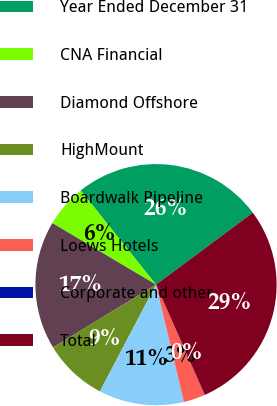Convert chart. <chart><loc_0><loc_0><loc_500><loc_500><pie_chart><fcel>Year Ended December 31<fcel>CNA Financial<fcel>Diamond Offshore<fcel>HighMount<fcel>Boardwalk Pipeline<fcel>Loews Hotels<fcel>Corporate and other<fcel>Total<nl><fcel>25.57%<fcel>5.73%<fcel>17.25%<fcel>8.58%<fcel>11.43%<fcel>2.88%<fcel>0.03%<fcel>28.54%<nl></chart> 